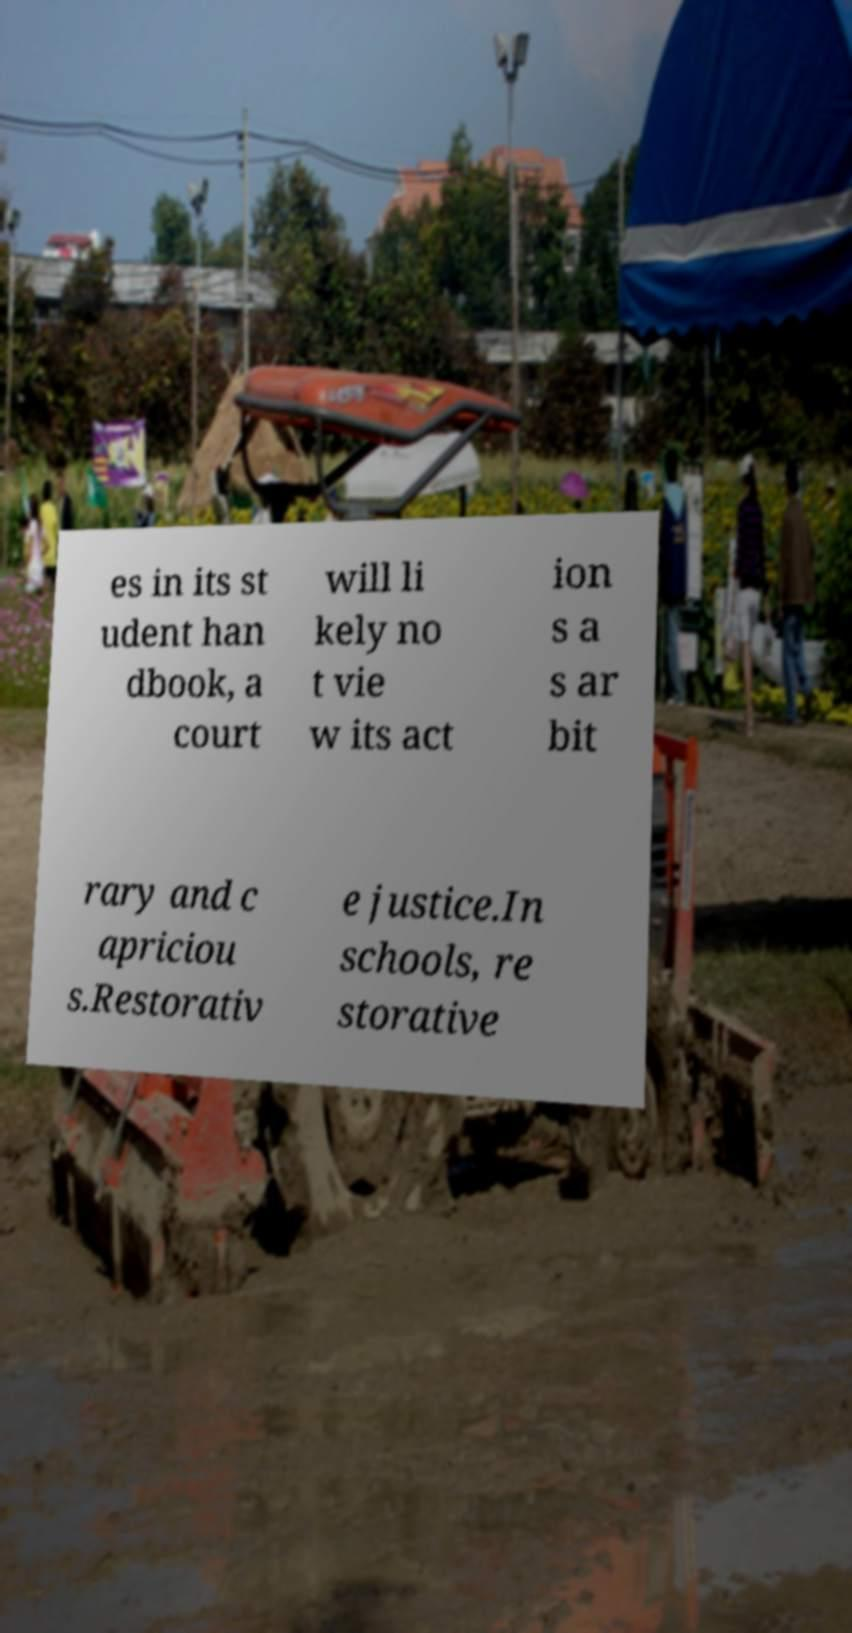For documentation purposes, I need the text within this image transcribed. Could you provide that? es in its st udent han dbook, a court will li kely no t vie w its act ion s a s ar bit rary and c apriciou s.Restorativ e justice.In schools, re storative 